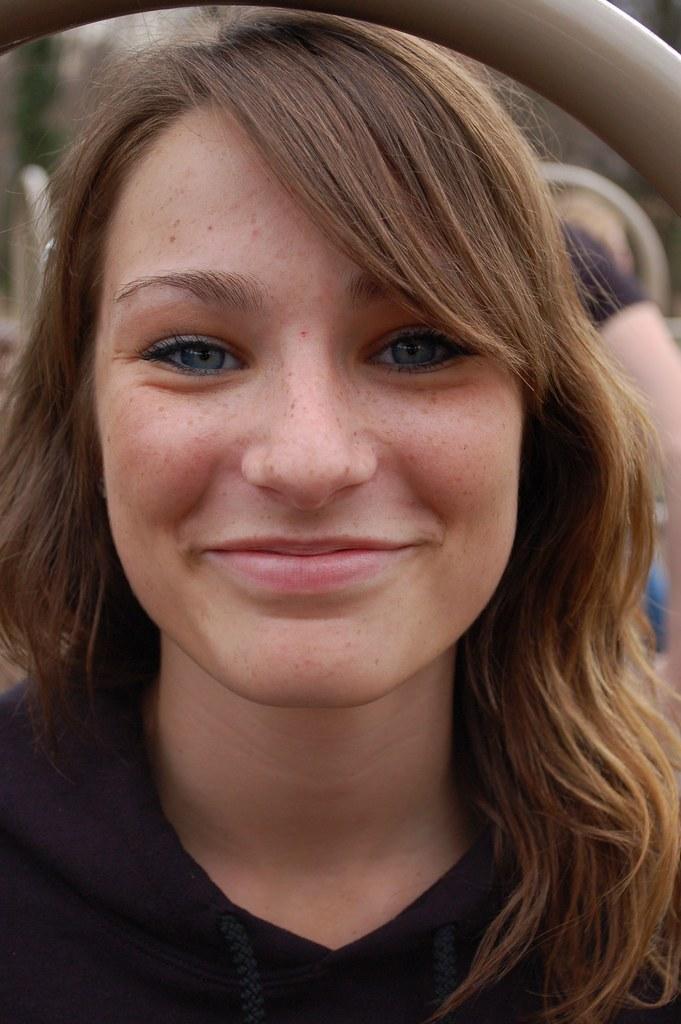Could you give a brief overview of what you see in this image? In this image we can see there is a woman in the foreground, smiling at someone and wearing a black dress. 